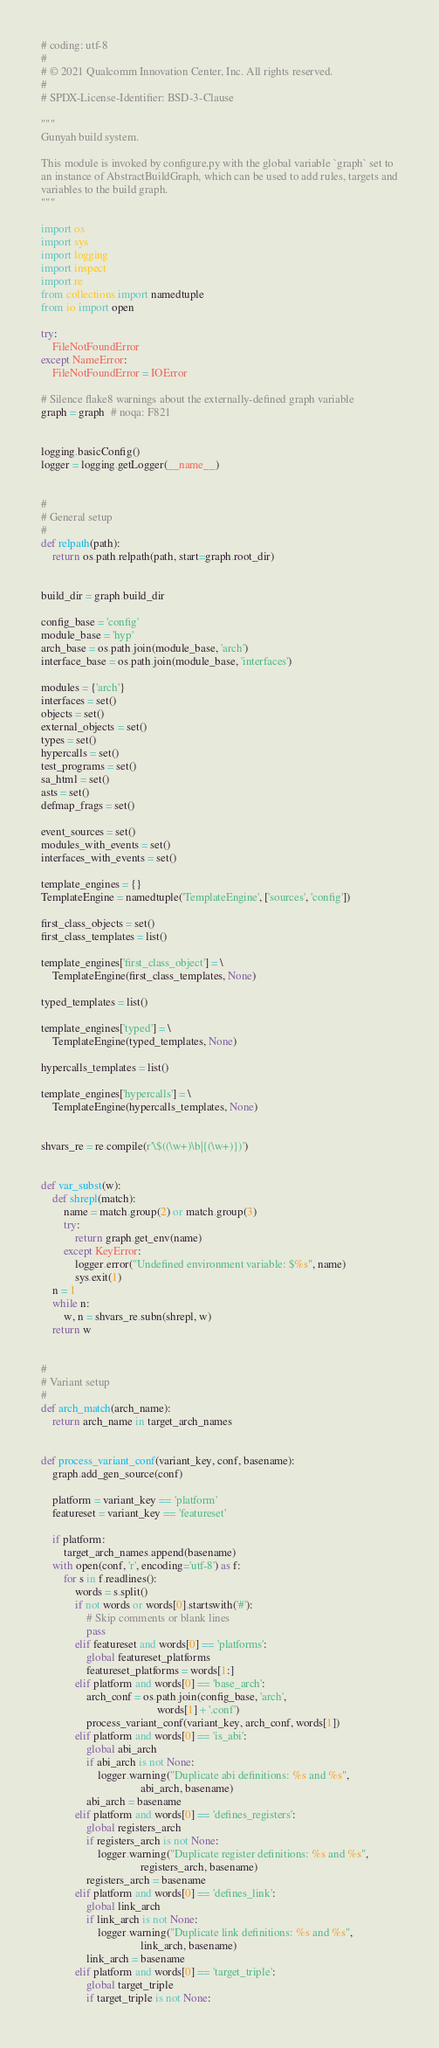Convert code to text. <code><loc_0><loc_0><loc_500><loc_500><_Python_># coding: utf-8
#
# © 2021 Qualcomm Innovation Center, Inc. All rights reserved.
#
# SPDX-License-Identifier: BSD-3-Clause

"""
Gunyah build system.

This module is invoked by configure.py with the global variable `graph` set to
an instance of AbstractBuildGraph, which can be used to add rules, targets and
variables to the build graph.
"""

import os
import sys
import logging
import inspect
import re
from collections import namedtuple
from io import open

try:
    FileNotFoundError
except NameError:
    FileNotFoundError = IOError

# Silence flake8 warnings about the externally-defined graph variable
graph = graph  # noqa: F821


logging.basicConfig()
logger = logging.getLogger(__name__)


#
# General setup
#
def relpath(path):
    return os.path.relpath(path, start=graph.root_dir)


build_dir = graph.build_dir

config_base = 'config'
module_base = 'hyp'
arch_base = os.path.join(module_base, 'arch')
interface_base = os.path.join(module_base, 'interfaces')

modules = {'arch'}
interfaces = set()
objects = set()
external_objects = set()
types = set()
hypercalls = set()
test_programs = set()
sa_html = set()
asts = set()
defmap_frags = set()

event_sources = set()
modules_with_events = set()
interfaces_with_events = set()

template_engines = {}
TemplateEngine = namedtuple('TemplateEngine', ['sources', 'config'])

first_class_objects = set()
first_class_templates = list()

template_engines['first_class_object'] = \
    TemplateEngine(first_class_templates, None)

typed_templates = list()

template_engines['typed'] = \
    TemplateEngine(typed_templates, None)

hypercalls_templates = list()

template_engines['hypercalls'] = \
    TemplateEngine(hypercalls_templates, None)


shvars_re = re.compile(r'\$((\w+)\b|{(\w+)})')


def var_subst(w):
    def shrepl(match):
        name = match.group(2) or match.group(3)
        try:
            return graph.get_env(name)
        except KeyError:
            logger.error("Undefined environment variable: $%s", name)
            sys.exit(1)
    n = 1
    while n:
        w, n = shvars_re.subn(shrepl, w)
    return w


#
# Variant setup
#
def arch_match(arch_name):
    return arch_name in target_arch_names


def process_variant_conf(variant_key, conf, basename):
    graph.add_gen_source(conf)

    platform = variant_key == 'platform'
    featureset = variant_key == 'featureset'

    if platform:
        target_arch_names.append(basename)
    with open(conf, 'r', encoding='utf-8') as f:
        for s in f.readlines():
            words = s.split()
            if not words or words[0].startswith('#'):
                # Skip comments or blank lines
                pass
            elif featureset and words[0] == 'platforms':
                global featureset_platforms
                featureset_platforms = words[1:]
            elif platform and words[0] == 'base_arch':
                arch_conf = os.path.join(config_base, 'arch',
                                         words[1] + '.conf')
                process_variant_conf(variant_key, arch_conf, words[1])
            elif platform and words[0] == 'is_abi':
                global abi_arch
                if abi_arch is not None:
                    logger.warning("Duplicate abi definitions: %s and %s",
                                   abi_arch, basename)
                abi_arch = basename
            elif platform and words[0] == 'defines_registers':
                global registers_arch
                if registers_arch is not None:
                    logger.warning("Duplicate register definitions: %s and %s",
                                   registers_arch, basename)
                registers_arch = basename
            elif platform and words[0] == 'defines_link':
                global link_arch
                if link_arch is not None:
                    logger.warning("Duplicate link definitions: %s and %s",
                                   link_arch, basename)
                link_arch = basename
            elif platform and words[0] == 'target_triple':
                global target_triple
                if target_triple is not None:</code> 